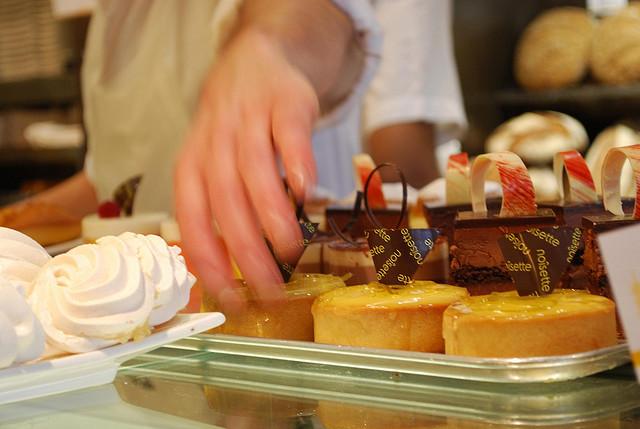What entree is this?
Quick response, please. Dessert. Is this food sweet?
Write a very short answer. Yes. Is the hand left or right?
Keep it brief. Left. 